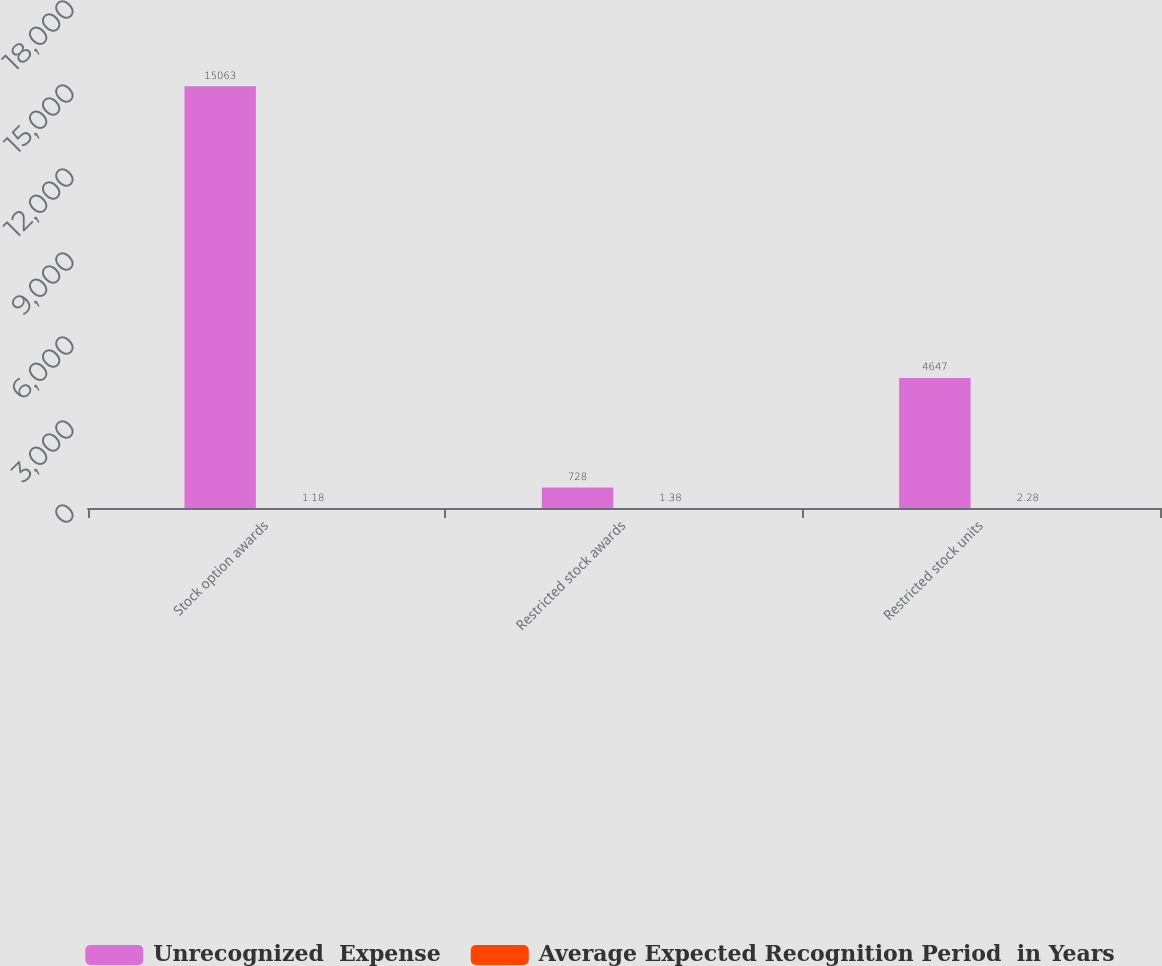<chart> <loc_0><loc_0><loc_500><loc_500><stacked_bar_chart><ecel><fcel>Stock option awards<fcel>Restricted stock awards<fcel>Restricted stock units<nl><fcel>Unrecognized  Expense<fcel>15063<fcel>728<fcel>4647<nl><fcel>Average Expected Recognition Period  in Years<fcel>1.18<fcel>1.38<fcel>2.28<nl></chart> 